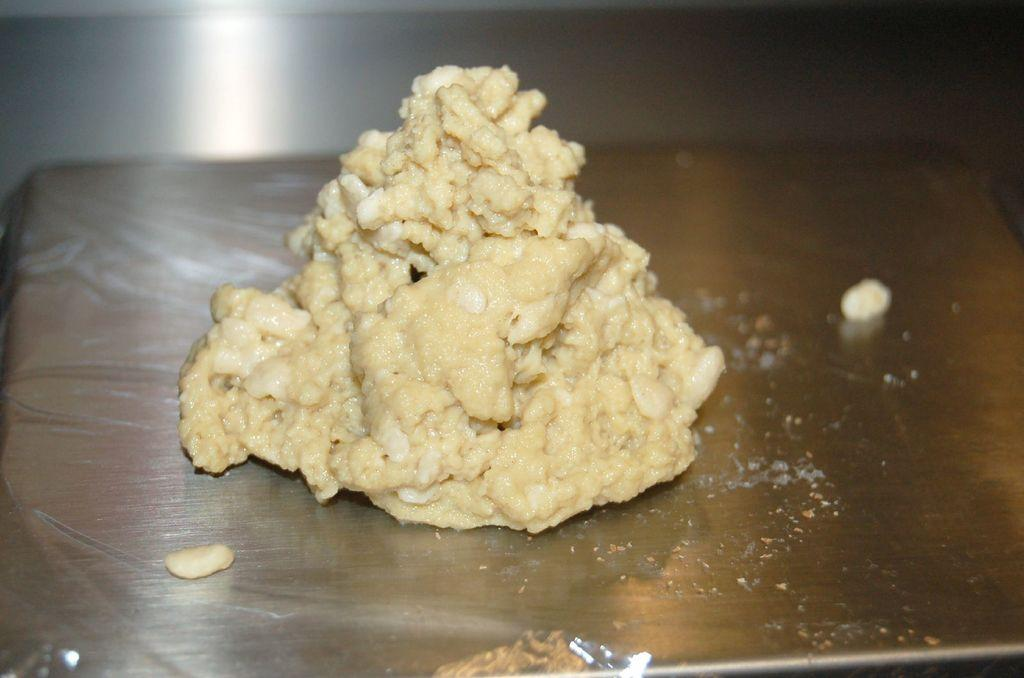What is the main subject of the picture? There is a food item in the picture. How is the food item placed in the image? The food item is on a sheet. What type of table is the sheet placed on? The sheet is on a steel table. How many patches can be seen on the toad in the image? There is no toad present in the image, and therefore no patches can be seen. 